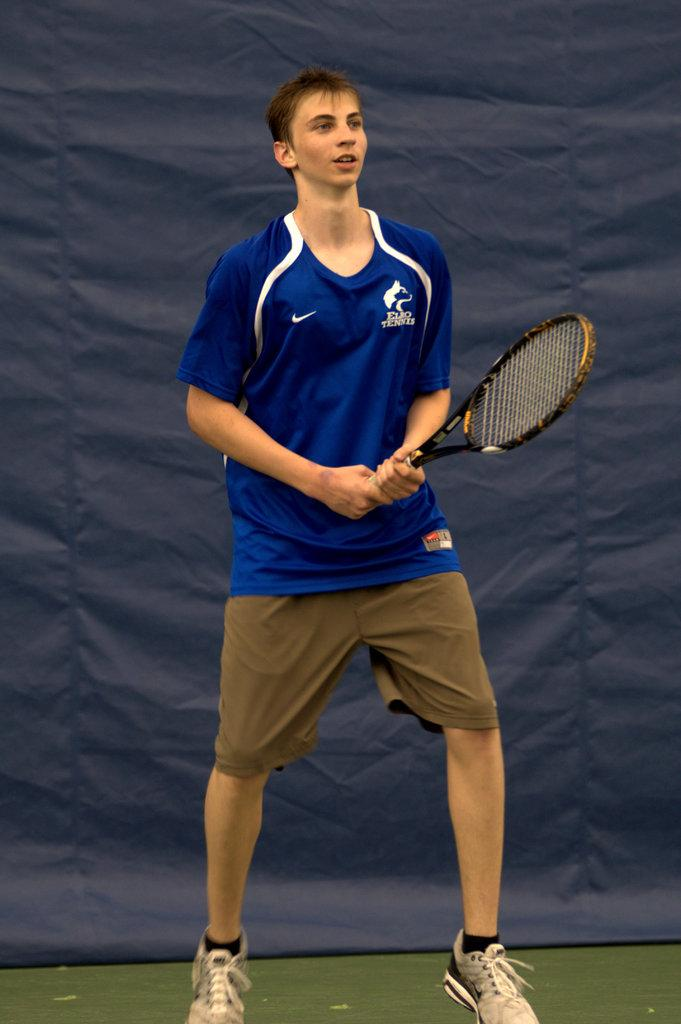What is the main subject of the image? The main subject of the image is a man. What is the man doing in the image? The man is standing in the image. What object is the man holding in his hand? The man is holding a tennis racket in his hand. Is there any additional information visible in the image? Yes, there is a banner visible in the image. What type of bread can be seen in the image? There is no bread present in the image. How many cows are visible in the image? There are no cows visible in the image. 